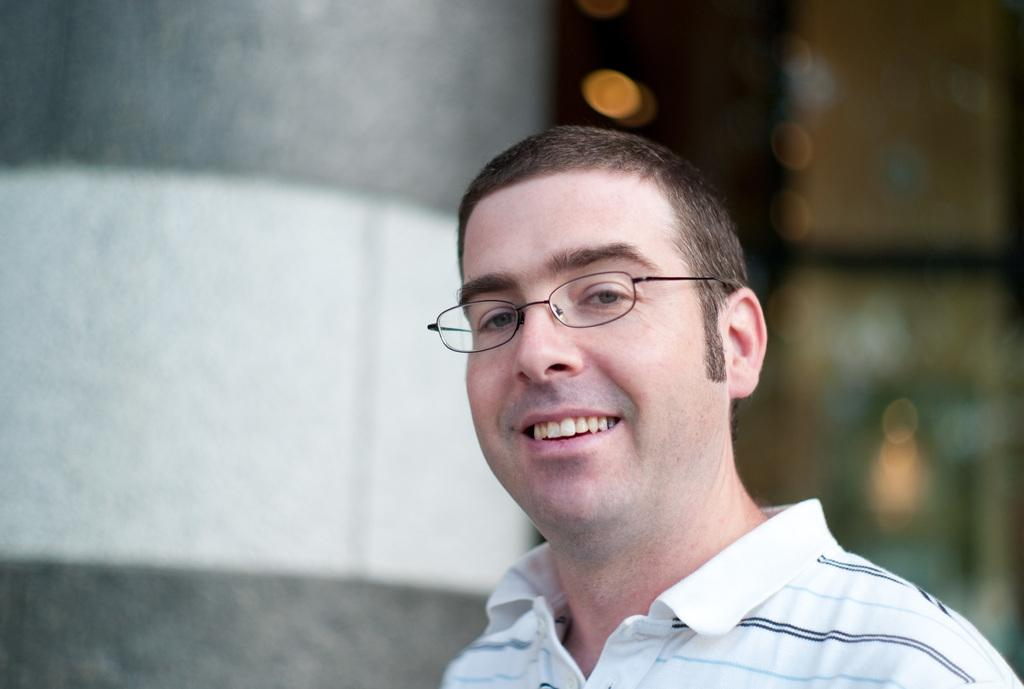What is the main subject of the image? There is a person in the image. What is the person wearing on their upper body? The person is wearing a white t-shirt. What type of eyewear is the person wearing? The person is wearing black-colored spectacles. What is the person's facial expression in the image? The person is smiling. How would you describe the background of the image? The background of the image is blurry. What type of alarm can be heard in the image? There is no audible alarm present in the image, as it is a still photograph. 